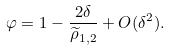<formula> <loc_0><loc_0><loc_500><loc_500>\varphi = 1 - \frac { 2 \delta } { \widetilde { \rho } _ { 1 , 2 } } + O ( \delta ^ { 2 } ) .</formula> 